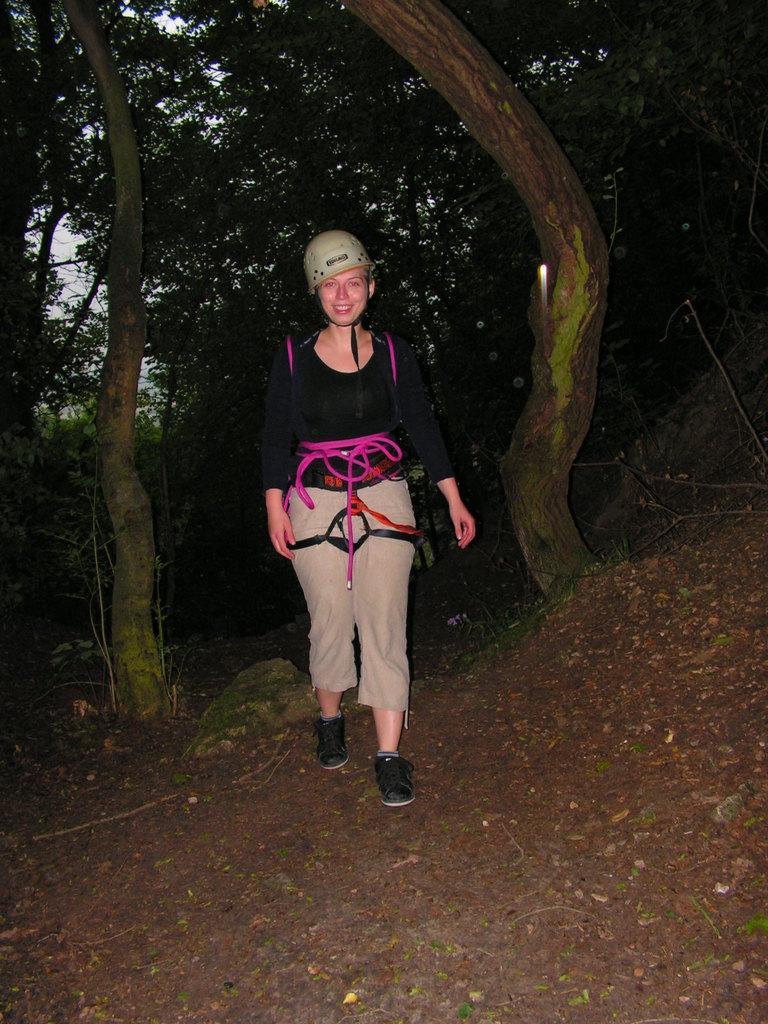In one or two sentences, can you explain what this image depicts? In the center of the picture there is a woman wearing backpack and helmet, walking. In the foreground there are dry leaves and soil. In the background there are trees. It is dark. 